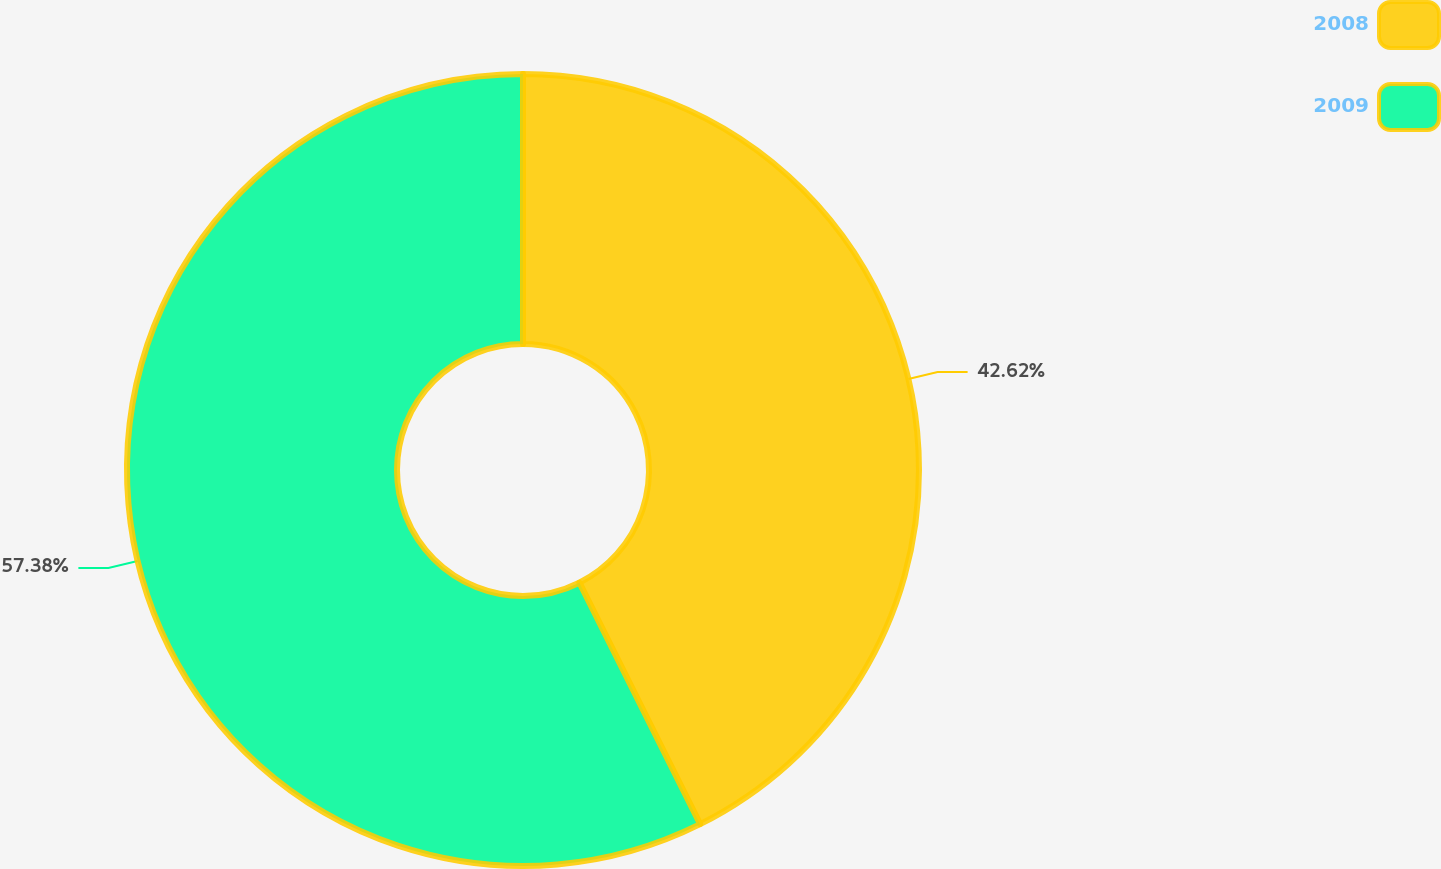Convert chart. <chart><loc_0><loc_0><loc_500><loc_500><pie_chart><fcel>2008<fcel>2009<nl><fcel>42.62%<fcel>57.38%<nl></chart> 